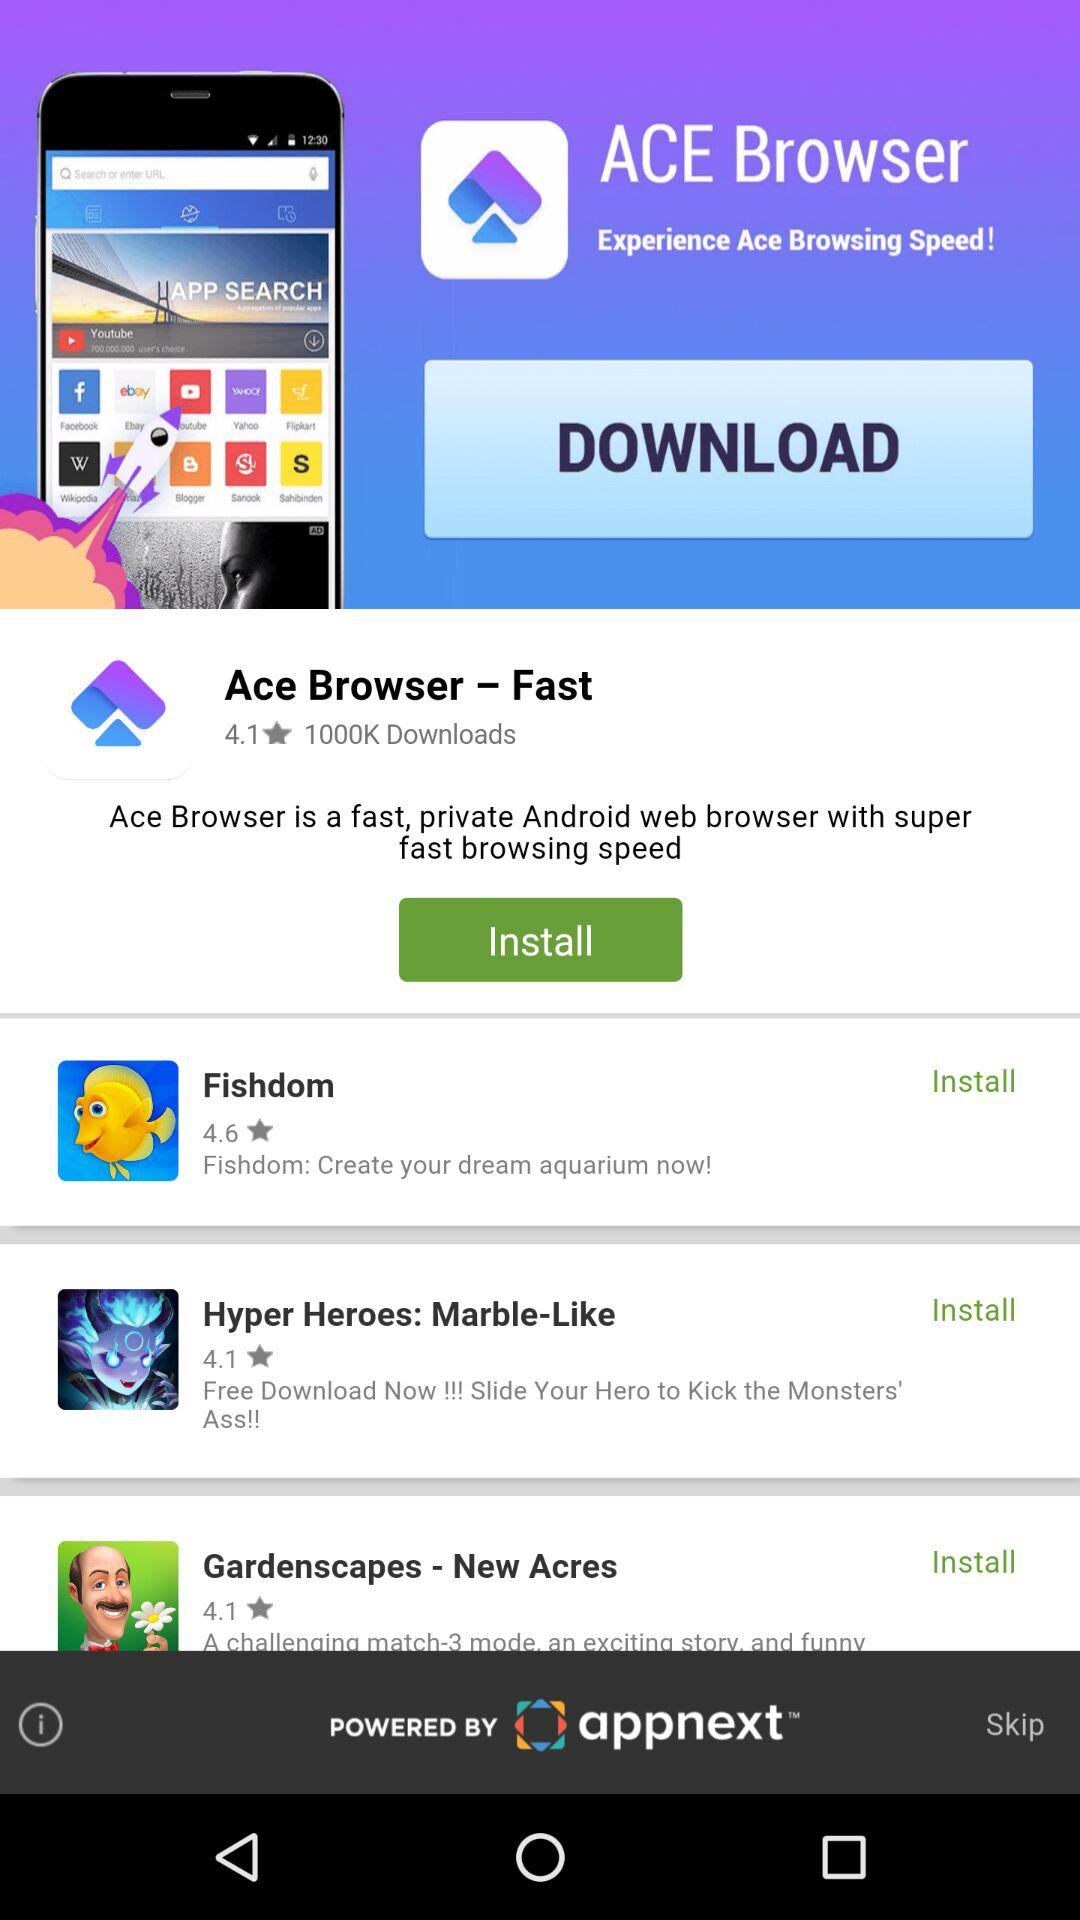What is the star rating of "Hyper Heroes: Marble-Like"? The rating is 4.1 stars. 